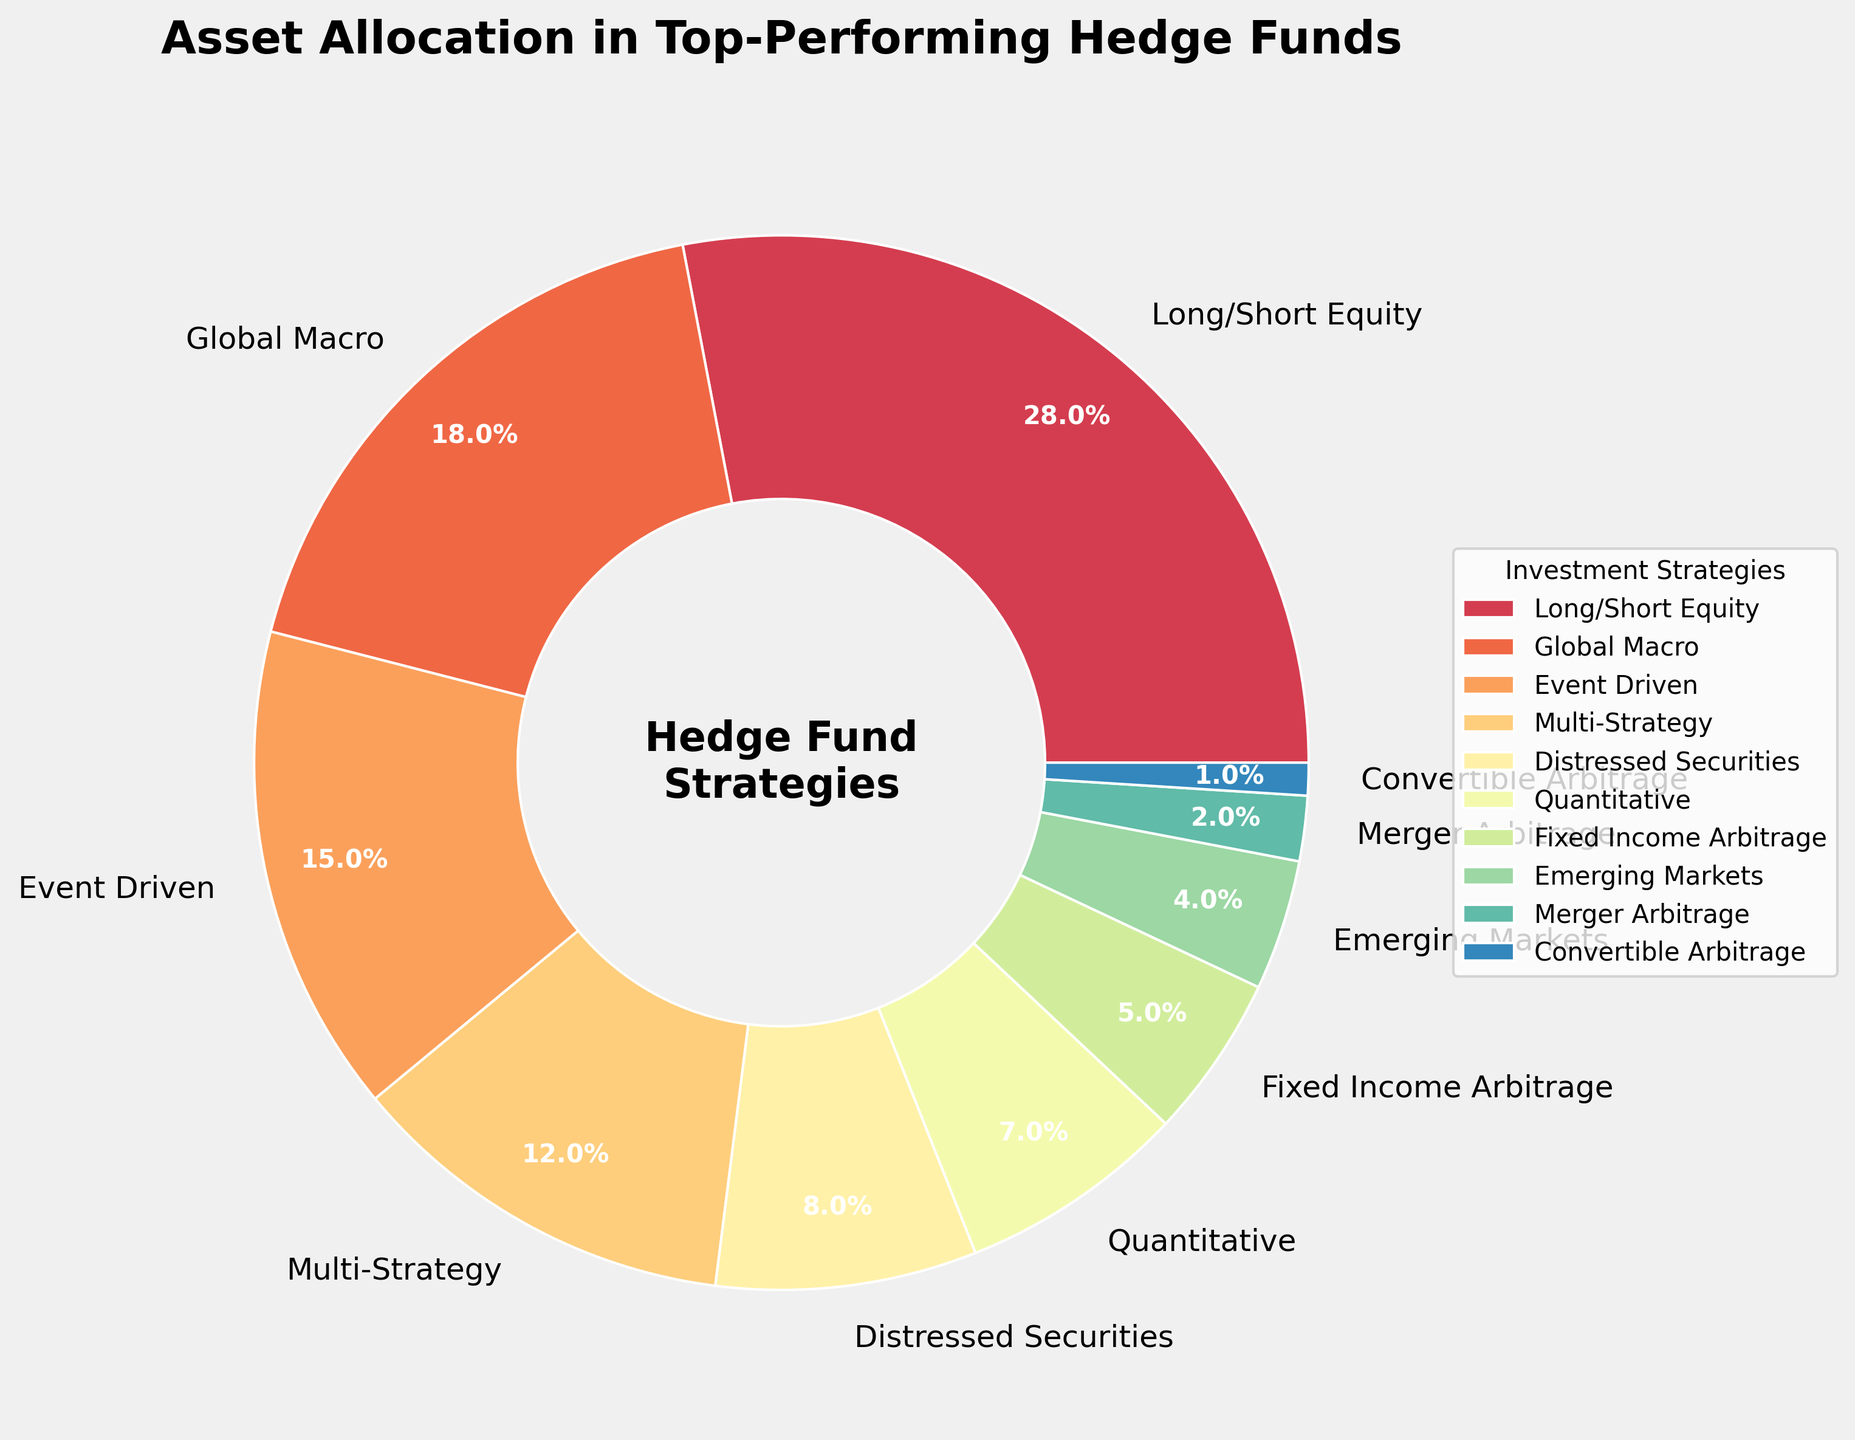What is the largest investment strategy by allocation in the chart? The largest investment strategy can be identified from the pie chart by finding the segment with the largest percentage allocation. The "Long/Short Equity" segment has the highest percentage at 28%.
Answer: Long/Short Equity Which two strategies have the smallest difference in their allocation percentages and what is that difference? First, extract the allocation percentages from the chart. The closest percentages are "Emerging Markets" (4%) and "Merger Arbitrage" (2%). The difference between them is \(4\% - 2\% = 2\%\).
Answer: Emerging Markets and Merger Arbitrage, 2% How much more is allocated to the Long/Short Equity strategy compared to the Quantitative strategy? Identify the percentages for Long/Short Equity (28%) and Quantitative (7%). The difference is calculated as \(28\% - 7\% = 21\%\).
Answer: 21% What is the combined allocation percentage for the top 3 strategies? Sum the percentages for the top 3 strategies: Long/Short Equity (28%), Global Macro (18%), and Event Driven (15%). The total is \( 28\% + 18\% + 15\% = 61\% \).
Answer: 61% Which strategy occupies the smallest portion of the pie chart, and what percentage does it represent? The segment representing the smallest portion of the pie chart is "Convertible Arbitrage" with a percentage of 1%.
Answer: Convertible Arbitrage, 1% How do the allocations for Global Macro and Event Driven compare? Identify the percentages for Global Macro (18%) and Event Driven (15%). Comparing these, Global Macro (18%) is greater than Event Driven (15%).
Answer: Global Macro is greater Which strategy situated in the top half of the chart has an allocation closest to the average allocation percentage of all strategies? Calculate the average percentage: Total allocation = 100% and there are 10 strategies, so average \( \frac{100}{10} = 10\% \). "Multi-Strategy" at 12% is the closest to the average among strategies constituting top half of the chart (>= 12%).
Answer: Multi-Strategy What is the total percentage allocation for strategies other than the top-performing one? The top-performing strategy is Long/Short Equity (28%). Subtract this from total allocation: \(100\% - 28\% = 72\% \).
Answer: 72% Which strategy, allocated at exactly 5%, represents a mid-tier investment strategy? From the pie chart, the strategy allocated exactly 5% is "Fixed Income Arbitrage."
Answer: Fixed Income Arbitrage 